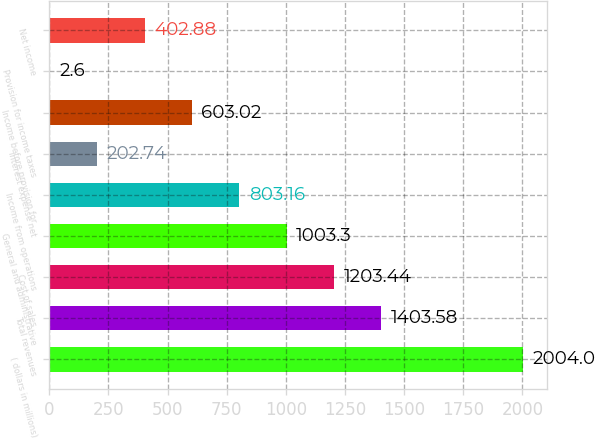Convert chart to OTSL. <chart><loc_0><loc_0><loc_500><loc_500><bar_chart><fcel>( dollars in millions)<fcel>Total revenues<fcel>Cost of sales<fcel>General and administrative<fcel>Income from operations<fcel>Interest expense net<fcel>Income before provision for<fcel>Provision for income taxes<fcel>Net income<nl><fcel>2004<fcel>1403.58<fcel>1203.44<fcel>1003.3<fcel>803.16<fcel>202.74<fcel>603.02<fcel>2.6<fcel>402.88<nl></chart> 